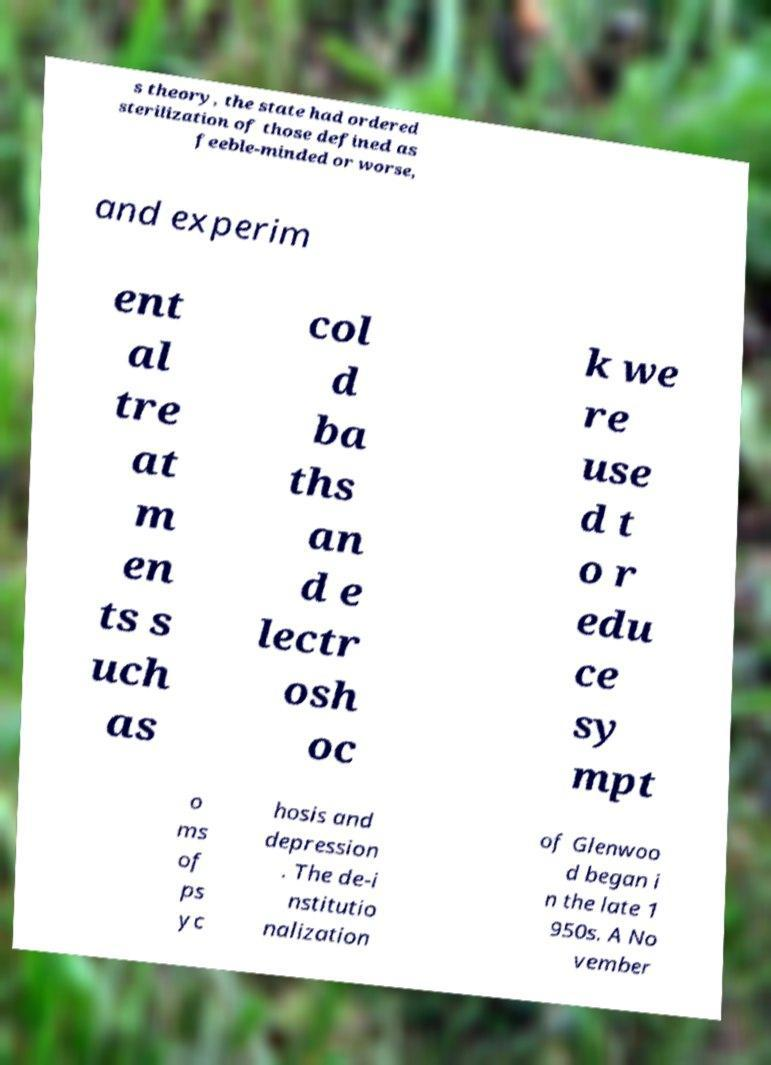Can you accurately transcribe the text from the provided image for me? s theory, the state had ordered sterilization of those defined as feeble-minded or worse, and experim ent al tre at m en ts s uch as col d ba ths an d e lectr osh oc k we re use d t o r edu ce sy mpt o ms of ps yc hosis and depression . The de-i nstitutio nalization of Glenwoo d began i n the late 1 950s. A No vember 